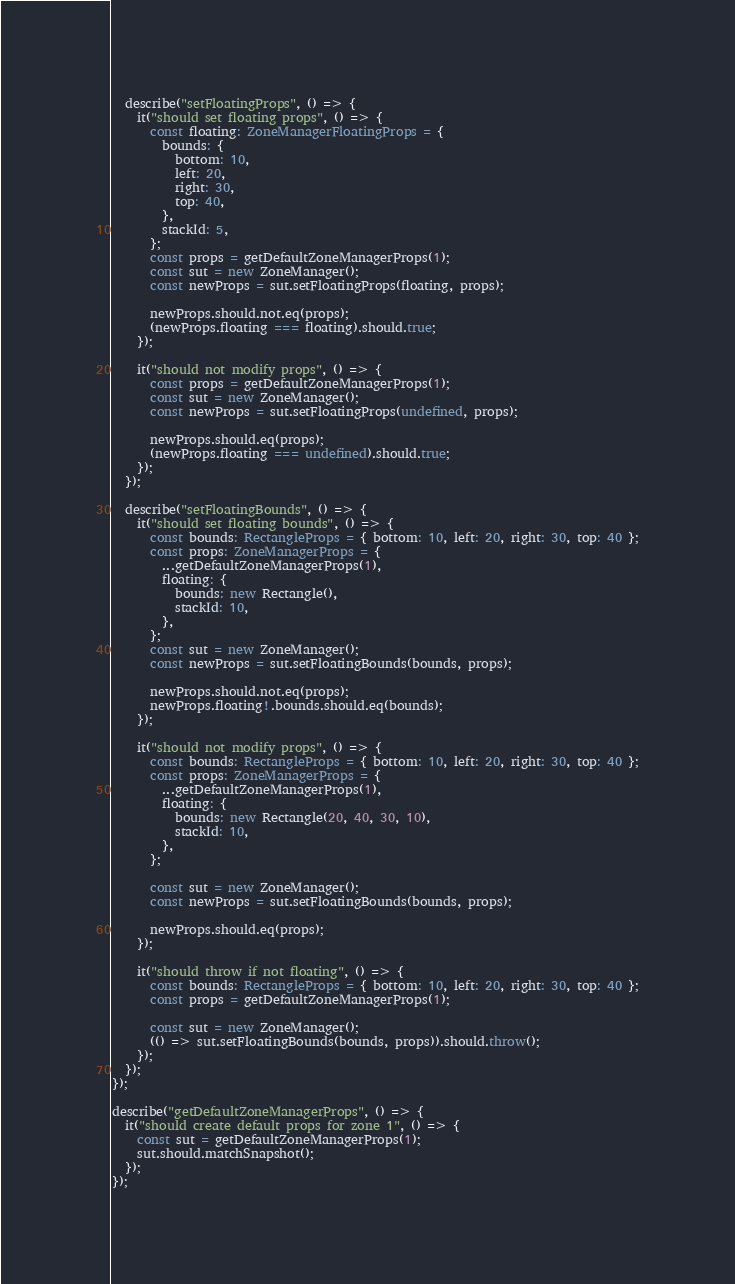<code> <loc_0><loc_0><loc_500><loc_500><_TypeScript_>
  describe("setFloatingProps", () => {
    it("should set floating props", () => {
      const floating: ZoneManagerFloatingProps = {
        bounds: {
          bottom: 10,
          left: 20,
          right: 30,
          top: 40,
        },
        stackId: 5,
      };
      const props = getDefaultZoneManagerProps(1);
      const sut = new ZoneManager();
      const newProps = sut.setFloatingProps(floating, props);

      newProps.should.not.eq(props);
      (newProps.floating === floating).should.true;
    });

    it("should not modify props", () => {
      const props = getDefaultZoneManagerProps(1);
      const sut = new ZoneManager();
      const newProps = sut.setFloatingProps(undefined, props);

      newProps.should.eq(props);
      (newProps.floating === undefined).should.true;
    });
  });

  describe("setFloatingBounds", () => {
    it("should set floating bounds", () => {
      const bounds: RectangleProps = { bottom: 10, left: 20, right: 30, top: 40 };
      const props: ZoneManagerProps = {
        ...getDefaultZoneManagerProps(1),
        floating: {
          bounds: new Rectangle(),
          stackId: 10,
        },
      };
      const sut = new ZoneManager();
      const newProps = sut.setFloatingBounds(bounds, props);

      newProps.should.not.eq(props);
      newProps.floating!.bounds.should.eq(bounds);
    });

    it("should not modify props", () => {
      const bounds: RectangleProps = { bottom: 10, left: 20, right: 30, top: 40 };
      const props: ZoneManagerProps = {
        ...getDefaultZoneManagerProps(1),
        floating: {
          bounds: new Rectangle(20, 40, 30, 10),
          stackId: 10,
        },
      };

      const sut = new ZoneManager();
      const newProps = sut.setFloatingBounds(bounds, props);

      newProps.should.eq(props);
    });

    it("should throw if not floating", () => {
      const bounds: RectangleProps = { bottom: 10, left: 20, right: 30, top: 40 };
      const props = getDefaultZoneManagerProps(1);

      const sut = new ZoneManager();
      (() => sut.setFloatingBounds(bounds, props)).should.throw();
    });
  });
});

describe("getDefaultZoneManagerProps", () => {
  it("should create default props for zone 1", () => {
    const sut = getDefaultZoneManagerProps(1);
    sut.should.matchSnapshot();
  });
});
</code> 